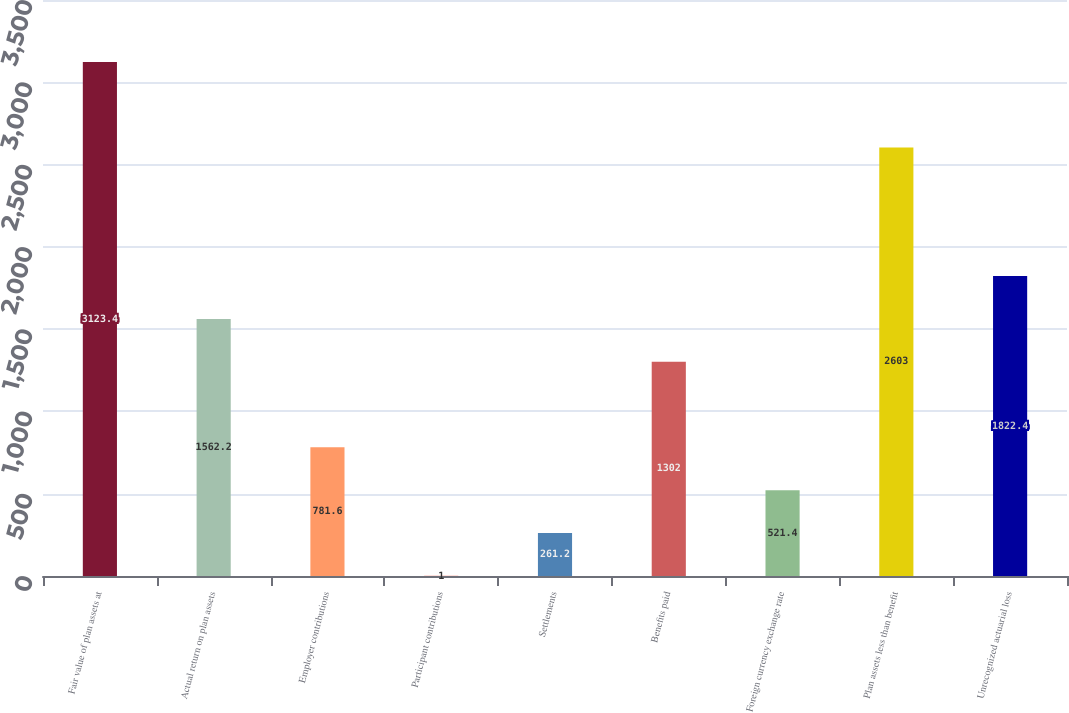<chart> <loc_0><loc_0><loc_500><loc_500><bar_chart><fcel>Fair value of plan assets at<fcel>Actual return on plan assets<fcel>Employer contributions<fcel>Participant contributions<fcel>Settlements<fcel>Benefits paid<fcel>Foreign currency exchange rate<fcel>Plan assets less than benefit<fcel>Unrecognized actuarial loss<nl><fcel>3123.4<fcel>1562.2<fcel>781.6<fcel>1<fcel>261.2<fcel>1302<fcel>521.4<fcel>2603<fcel>1822.4<nl></chart> 